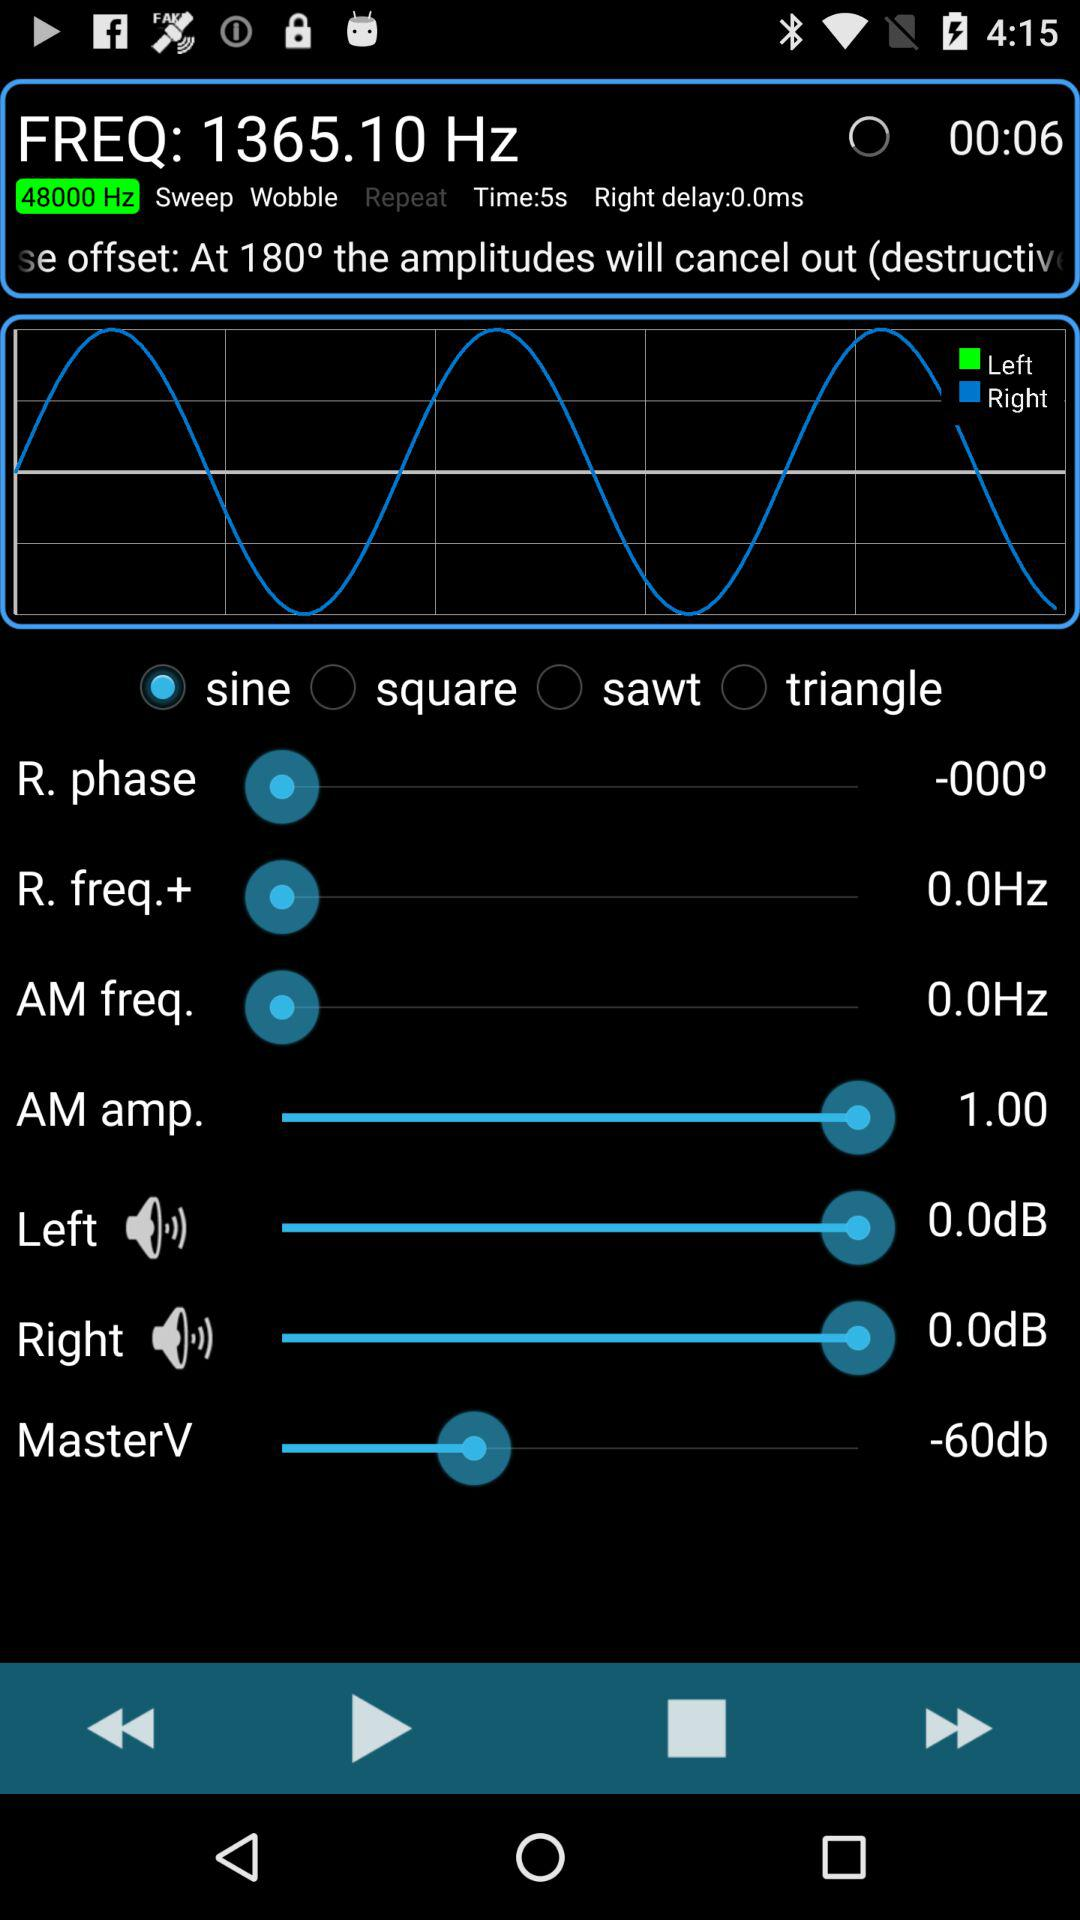Which frequency is set? The set frequency is 1365.10 Hz. 